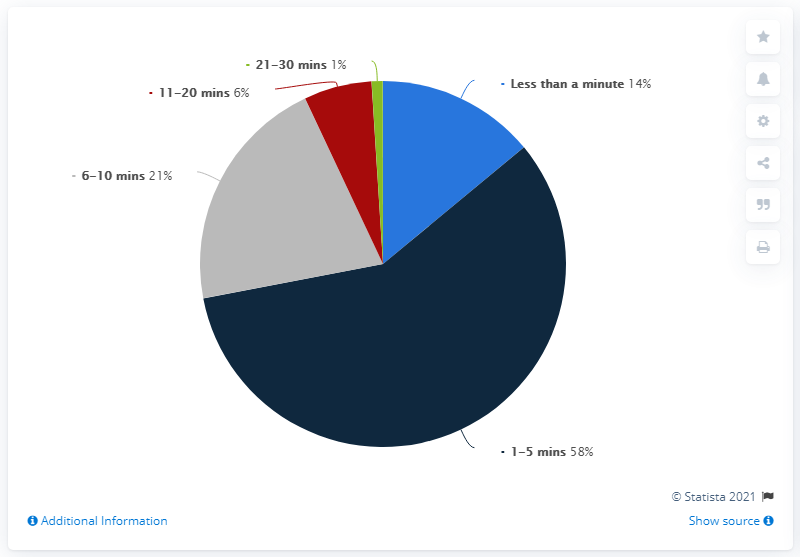Outline some significant characteristics in this image. The longest wait time for a screening was 1-5 minutes. Approximately 7% of individuals waited for longer than 11 minutes. 